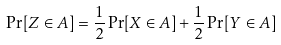<formula> <loc_0><loc_0><loc_500><loc_500>\Pr [ Z \in A ] = \frac { 1 } { 2 } \Pr [ X \in A ] + \frac { 1 } { 2 } \Pr [ Y \in A ]</formula> 